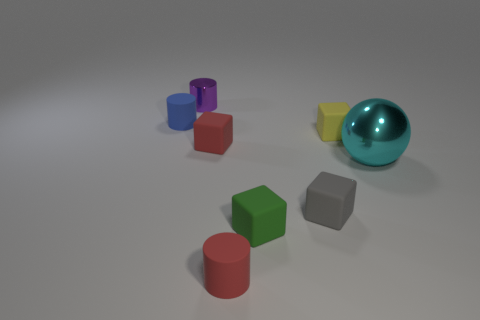Do the large metal ball and the metallic cylinder have the same color?
Give a very brief answer. No. Is the number of gray rubber objects in front of the large metal object the same as the number of small green rubber objects that are in front of the red rubber cylinder?
Offer a terse response. No. The big object is what color?
Offer a terse response. Cyan. What number of objects are either tiny cylinders behind the tiny blue matte cylinder or rubber cylinders?
Give a very brief answer. 3. Does the metal thing in front of the tiny purple cylinder have the same size as the shiny object on the left side of the green block?
Keep it short and to the point. No. Are there any other things that are made of the same material as the small green cube?
Provide a succinct answer. Yes. How many objects are either rubber cylinders in front of the big object or tiny rubber cubes left of the green thing?
Offer a terse response. 2. Is the cyan object made of the same material as the tiny red thing behind the red rubber cylinder?
Your response must be concise. No. The object that is both to the right of the gray matte block and on the left side of the cyan metallic sphere has what shape?
Ensure brevity in your answer.  Cube. What is the shape of the green rubber object?
Make the answer very short. Cube. 